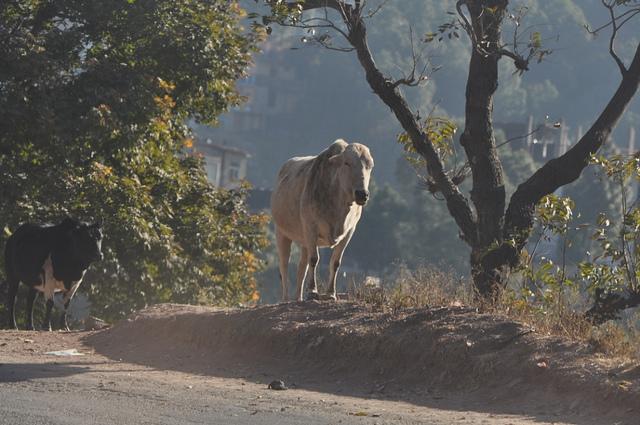Is the light coming from the left?
Quick response, please. No. What type of animals are shown?
Keep it brief. Cow. Is the dog about to fall off of the cliff?
Keep it brief. No. Is it cold in the picture?
Short answer required. No. What are the Rams climbing on?
Concise answer only. Dirt. What color is the animal on the mound?
Concise answer only. White. How many animals?
Write a very short answer. 2. 